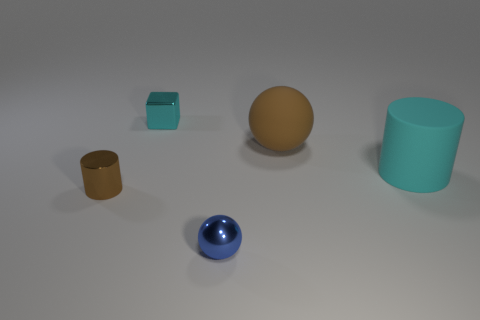Add 3 large brown spheres. How many large brown spheres are left? 4 Add 3 big brown rubber objects. How many big brown rubber objects exist? 4 Add 3 blue metallic balls. How many objects exist? 8 Subtract 0 purple balls. How many objects are left? 5 Subtract all balls. How many objects are left? 3 Subtract 2 cylinders. How many cylinders are left? 0 Subtract all blue balls. Subtract all purple cubes. How many balls are left? 1 Subtract all gray cylinders. How many brown cubes are left? 0 Subtract all big spheres. Subtract all tiny cyan cubes. How many objects are left? 3 